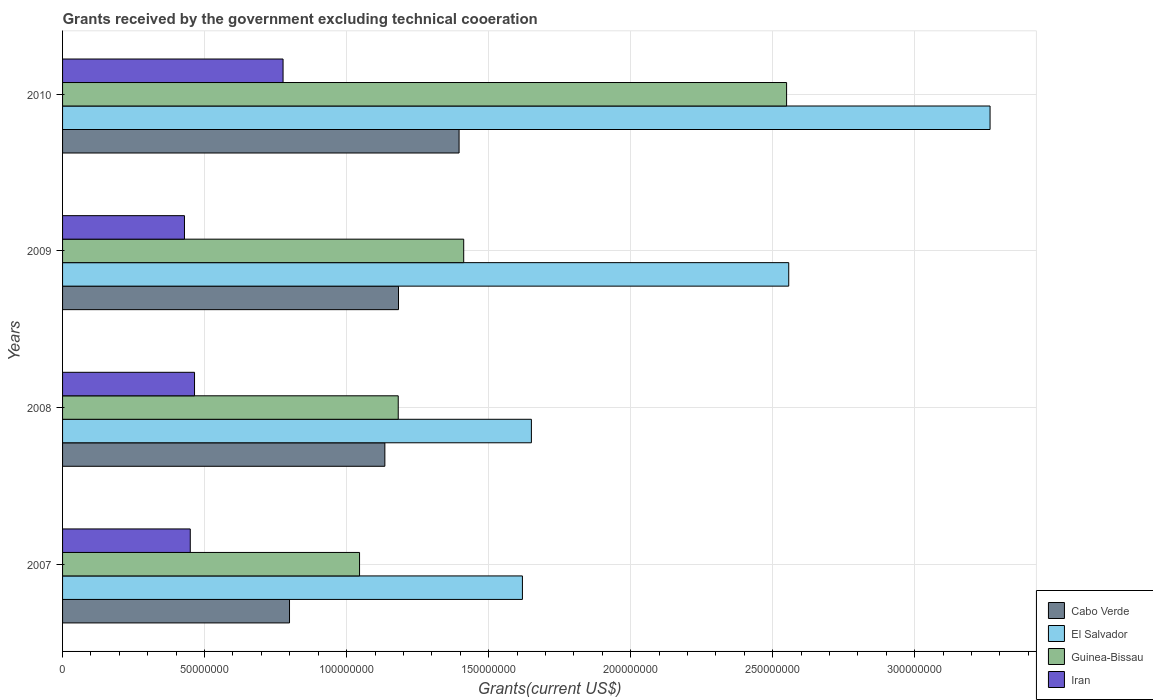How many different coloured bars are there?
Keep it short and to the point. 4. What is the label of the 2nd group of bars from the top?
Give a very brief answer. 2009. In how many cases, is the number of bars for a given year not equal to the number of legend labels?
Your answer should be compact. 0. What is the total grants received by the government in El Salvador in 2008?
Provide a succinct answer. 1.65e+08. Across all years, what is the maximum total grants received by the government in Guinea-Bissau?
Make the answer very short. 2.55e+08. Across all years, what is the minimum total grants received by the government in Cabo Verde?
Keep it short and to the point. 7.99e+07. What is the total total grants received by the government in El Salvador in the graph?
Offer a terse response. 9.09e+08. What is the difference between the total grants received by the government in El Salvador in 2009 and that in 2010?
Make the answer very short. -7.09e+07. What is the difference between the total grants received by the government in Cabo Verde in 2010 and the total grants received by the government in Guinea-Bissau in 2009?
Offer a very short reply. -1.63e+06. What is the average total grants received by the government in Iran per year?
Your response must be concise. 5.30e+07. In the year 2009, what is the difference between the total grants received by the government in Guinea-Bissau and total grants received by the government in Iran?
Offer a very short reply. 9.83e+07. In how many years, is the total grants received by the government in Iran greater than 70000000 US$?
Make the answer very short. 1. What is the ratio of the total grants received by the government in Iran in 2008 to that in 2010?
Offer a very short reply. 0.6. What is the difference between the highest and the second highest total grants received by the government in Guinea-Bissau?
Your answer should be compact. 1.14e+08. What is the difference between the highest and the lowest total grants received by the government in Guinea-Bissau?
Ensure brevity in your answer.  1.50e+08. In how many years, is the total grants received by the government in Cabo Verde greater than the average total grants received by the government in Cabo Verde taken over all years?
Provide a short and direct response. 3. Is it the case that in every year, the sum of the total grants received by the government in Cabo Verde and total grants received by the government in Iran is greater than the sum of total grants received by the government in El Salvador and total grants received by the government in Guinea-Bissau?
Your response must be concise. Yes. What does the 1st bar from the top in 2007 represents?
Ensure brevity in your answer.  Iran. What does the 4th bar from the bottom in 2009 represents?
Provide a short and direct response. Iran. Is it the case that in every year, the sum of the total grants received by the government in Iran and total grants received by the government in El Salvador is greater than the total grants received by the government in Guinea-Bissau?
Your answer should be compact. Yes. How many bars are there?
Provide a short and direct response. 16. What is the difference between two consecutive major ticks on the X-axis?
Ensure brevity in your answer.  5.00e+07. Are the values on the major ticks of X-axis written in scientific E-notation?
Your response must be concise. No. Does the graph contain any zero values?
Your answer should be very brief. No. Does the graph contain grids?
Your answer should be very brief. Yes. Where does the legend appear in the graph?
Offer a very short reply. Bottom right. How many legend labels are there?
Offer a terse response. 4. How are the legend labels stacked?
Provide a succinct answer. Vertical. What is the title of the graph?
Ensure brevity in your answer.  Grants received by the government excluding technical cooeration. Does "Lithuania" appear as one of the legend labels in the graph?
Ensure brevity in your answer.  No. What is the label or title of the X-axis?
Provide a succinct answer. Grants(current US$). What is the Grants(current US$) of Cabo Verde in 2007?
Your response must be concise. 7.99e+07. What is the Grants(current US$) of El Salvador in 2007?
Make the answer very short. 1.62e+08. What is the Grants(current US$) of Guinea-Bissau in 2007?
Offer a terse response. 1.05e+08. What is the Grants(current US$) in Iran in 2007?
Keep it short and to the point. 4.50e+07. What is the Grants(current US$) of Cabo Verde in 2008?
Your response must be concise. 1.13e+08. What is the Grants(current US$) in El Salvador in 2008?
Provide a succinct answer. 1.65e+08. What is the Grants(current US$) of Guinea-Bissau in 2008?
Keep it short and to the point. 1.18e+08. What is the Grants(current US$) of Iran in 2008?
Make the answer very short. 4.65e+07. What is the Grants(current US$) of Cabo Verde in 2009?
Provide a short and direct response. 1.18e+08. What is the Grants(current US$) in El Salvador in 2009?
Make the answer very short. 2.56e+08. What is the Grants(current US$) of Guinea-Bissau in 2009?
Offer a terse response. 1.41e+08. What is the Grants(current US$) in Iran in 2009?
Ensure brevity in your answer.  4.29e+07. What is the Grants(current US$) of Cabo Verde in 2010?
Keep it short and to the point. 1.40e+08. What is the Grants(current US$) of El Salvador in 2010?
Provide a succinct answer. 3.27e+08. What is the Grants(current US$) in Guinea-Bissau in 2010?
Offer a terse response. 2.55e+08. What is the Grants(current US$) of Iran in 2010?
Give a very brief answer. 7.76e+07. Across all years, what is the maximum Grants(current US$) of Cabo Verde?
Your answer should be very brief. 1.40e+08. Across all years, what is the maximum Grants(current US$) of El Salvador?
Offer a very short reply. 3.27e+08. Across all years, what is the maximum Grants(current US$) in Guinea-Bissau?
Offer a very short reply. 2.55e+08. Across all years, what is the maximum Grants(current US$) of Iran?
Provide a short and direct response. 7.76e+07. Across all years, what is the minimum Grants(current US$) of Cabo Verde?
Give a very brief answer. 7.99e+07. Across all years, what is the minimum Grants(current US$) of El Salvador?
Keep it short and to the point. 1.62e+08. Across all years, what is the minimum Grants(current US$) of Guinea-Bissau?
Give a very brief answer. 1.05e+08. Across all years, what is the minimum Grants(current US$) of Iran?
Give a very brief answer. 4.29e+07. What is the total Grants(current US$) of Cabo Verde in the graph?
Provide a succinct answer. 4.51e+08. What is the total Grants(current US$) in El Salvador in the graph?
Your answer should be compact. 9.09e+08. What is the total Grants(current US$) of Guinea-Bissau in the graph?
Ensure brevity in your answer.  6.19e+08. What is the total Grants(current US$) in Iran in the graph?
Offer a very short reply. 2.12e+08. What is the difference between the Grants(current US$) of Cabo Verde in 2007 and that in 2008?
Provide a succinct answer. -3.36e+07. What is the difference between the Grants(current US$) of El Salvador in 2007 and that in 2008?
Offer a very short reply. -3.16e+06. What is the difference between the Grants(current US$) in Guinea-Bissau in 2007 and that in 2008?
Give a very brief answer. -1.36e+07. What is the difference between the Grants(current US$) of Iran in 2007 and that in 2008?
Offer a terse response. -1.50e+06. What is the difference between the Grants(current US$) of Cabo Verde in 2007 and that in 2009?
Your response must be concise. -3.84e+07. What is the difference between the Grants(current US$) in El Salvador in 2007 and that in 2009?
Provide a short and direct response. -9.38e+07. What is the difference between the Grants(current US$) in Guinea-Bissau in 2007 and that in 2009?
Your response must be concise. -3.67e+07. What is the difference between the Grants(current US$) of Iran in 2007 and that in 2009?
Your answer should be very brief. 2.04e+06. What is the difference between the Grants(current US$) of Cabo Verde in 2007 and that in 2010?
Give a very brief answer. -5.97e+07. What is the difference between the Grants(current US$) of El Salvador in 2007 and that in 2010?
Provide a succinct answer. -1.65e+08. What is the difference between the Grants(current US$) in Guinea-Bissau in 2007 and that in 2010?
Provide a short and direct response. -1.50e+08. What is the difference between the Grants(current US$) of Iran in 2007 and that in 2010?
Ensure brevity in your answer.  -3.27e+07. What is the difference between the Grants(current US$) in Cabo Verde in 2008 and that in 2009?
Make the answer very short. -4.80e+06. What is the difference between the Grants(current US$) in El Salvador in 2008 and that in 2009?
Provide a short and direct response. -9.06e+07. What is the difference between the Grants(current US$) in Guinea-Bissau in 2008 and that in 2009?
Keep it short and to the point. -2.30e+07. What is the difference between the Grants(current US$) in Iran in 2008 and that in 2009?
Ensure brevity in your answer.  3.54e+06. What is the difference between the Grants(current US$) in Cabo Verde in 2008 and that in 2010?
Keep it short and to the point. -2.61e+07. What is the difference between the Grants(current US$) of El Salvador in 2008 and that in 2010?
Your response must be concise. -1.61e+08. What is the difference between the Grants(current US$) of Guinea-Bissau in 2008 and that in 2010?
Your response must be concise. -1.37e+08. What is the difference between the Grants(current US$) of Iran in 2008 and that in 2010?
Ensure brevity in your answer.  -3.12e+07. What is the difference between the Grants(current US$) in Cabo Verde in 2009 and that in 2010?
Give a very brief answer. -2.13e+07. What is the difference between the Grants(current US$) of El Salvador in 2009 and that in 2010?
Offer a terse response. -7.09e+07. What is the difference between the Grants(current US$) in Guinea-Bissau in 2009 and that in 2010?
Ensure brevity in your answer.  -1.14e+08. What is the difference between the Grants(current US$) of Iran in 2009 and that in 2010?
Offer a very short reply. -3.47e+07. What is the difference between the Grants(current US$) of Cabo Verde in 2007 and the Grants(current US$) of El Salvador in 2008?
Offer a very short reply. -8.52e+07. What is the difference between the Grants(current US$) of Cabo Verde in 2007 and the Grants(current US$) of Guinea-Bissau in 2008?
Provide a succinct answer. -3.83e+07. What is the difference between the Grants(current US$) of Cabo Verde in 2007 and the Grants(current US$) of Iran in 2008?
Provide a short and direct response. 3.34e+07. What is the difference between the Grants(current US$) in El Salvador in 2007 and the Grants(current US$) in Guinea-Bissau in 2008?
Your answer should be very brief. 4.37e+07. What is the difference between the Grants(current US$) in El Salvador in 2007 and the Grants(current US$) in Iran in 2008?
Offer a very short reply. 1.15e+08. What is the difference between the Grants(current US$) of Guinea-Bissau in 2007 and the Grants(current US$) of Iran in 2008?
Keep it short and to the point. 5.81e+07. What is the difference between the Grants(current US$) in Cabo Verde in 2007 and the Grants(current US$) in El Salvador in 2009?
Your answer should be very brief. -1.76e+08. What is the difference between the Grants(current US$) in Cabo Verde in 2007 and the Grants(current US$) in Guinea-Bissau in 2009?
Make the answer very short. -6.13e+07. What is the difference between the Grants(current US$) in Cabo Verde in 2007 and the Grants(current US$) in Iran in 2009?
Provide a short and direct response. 3.70e+07. What is the difference between the Grants(current US$) of El Salvador in 2007 and the Grants(current US$) of Guinea-Bissau in 2009?
Your answer should be compact. 2.07e+07. What is the difference between the Grants(current US$) of El Salvador in 2007 and the Grants(current US$) of Iran in 2009?
Offer a very short reply. 1.19e+08. What is the difference between the Grants(current US$) of Guinea-Bissau in 2007 and the Grants(current US$) of Iran in 2009?
Offer a terse response. 6.16e+07. What is the difference between the Grants(current US$) in Cabo Verde in 2007 and the Grants(current US$) in El Salvador in 2010?
Your response must be concise. -2.47e+08. What is the difference between the Grants(current US$) in Cabo Verde in 2007 and the Grants(current US$) in Guinea-Bissau in 2010?
Provide a short and direct response. -1.75e+08. What is the difference between the Grants(current US$) of Cabo Verde in 2007 and the Grants(current US$) of Iran in 2010?
Your answer should be compact. 2.27e+06. What is the difference between the Grants(current US$) in El Salvador in 2007 and the Grants(current US$) in Guinea-Bissau in 2010?
Your answer should be compact. -9.30e+07. What is the difference between the Grants(current US$) in El Salvador in 2007 and the Grants(current US$) in Iran in 2010?
Offer a very short reply. 8.43e+07. What is the difference between the Grants(current US$) in Guinea-Bissau in 2007 and the Grants(current US$) in Iran in 2010?
Ensure brevity in your answer.  2.69e+07. What is the difference between the Grants(current US$) in Cabo Verde in 2008 and the Grants(current US$) in El Salvador in 2009?
Keep it short and to the point. -1.42e+08. What is the difference between the Grants(current US$) in Cabo Verde in 2008 and the Grants(current US$) in Guinea-Bissau in 2009?
Offer a terse response. -2.78e+07. What is the difference between the Grants(current US$) in Cabo Verde in 2008 and the Grants(current US$) in Iran in 2009?
Offer a terse response. 7.06e+07. What is the difference between the Grants(current US$) of El Salvador in 2008 and the Grants(current US$) of Guinea-Bissau in 2009?
Provide a succinct answer. 2.38e+07. What is the difference between the Grants(current US$) of El Salvador in 2008 and the Grants(current US$) of Iran in 2009?
Provide a short and direct response. 1.22e+08. What is the difference between the Grants(current US$) of Guinea-Bissau in 2008 and the Grants(current US$) of Iran in 2009?
Provide a succinct answer. 7.53e+07. What is the difference between the Grants(current US$) in Cabo Verde in 2008 and the Grants(current US$) in El Salvador in 2010?
Offer a very short reply. -2.13e+08. What is the difference between the Grants(current US$) of Cabo Verde in 2008 and the Grants(current US$) of Guinea-Bissau in 2010?
Your answer should be compact. -1.41e+08. What is the difference between the Grants(current US$) in Cabo Verde in 2008 and the Grants(current US$) in Iran in 2010?
Ensure brevity in your answer.  3.58e+07. What is the difference between the Grants(current US$) of El Salvador in 2008 and the Grants(current US$) of Guinea-Bissau in 2010?
Keep it short and to the point. -8.98e+07. What is the difference between the Grants(current US$) in El Salvador in 2008 and the Grants(current US$) in Iran in 2010?
Ensure brevity in your answer.  8.74e+07. What is the difference between the Grants(current US$) in Guinea-Bissau in 2008 and the Grants(current US$) in Iran in 2010?
Your answer should be very brief. 4.06e+07. What is the difference between the Grants(current US$) in Cabo Verde in 2009 and the Grants(current US$) in El Salvador in 2010?
Your response must be concise. -2.08e+08. What is the difference between the Grants(current US$) of Cabo Verde in 2009 and the Grants(current US$) of Guinea-Bissau in 2010?
Offer a terse response. -1.37e+08. What is the difference between the Grants(current US$) of Cabo Verde in 2009 and the Grants(current US$) of Iran in 2010?
Your answer should be compact. 4.06e+07. What is the difference between the Grants(current US$) of El Salvador in 2009 and the Grants(current US$) of Guinea-Bissau in 2010?
Provide a short and direct response. 7.50e+05. What is the difference between the Grants(current US$) in El Salvador in 2009 and the Grants(current US$) in Iran in 2010?
Your answer should be compact. 1.78e+08. What is the difference between the Grants(current US$) of Guinea-Bissau in 2009 and the Grants(current US$) of Iran in 2010?
Your answer should be compact. 6.36e+07. What is the average Grants(current US$) in Cabo Verde per year?
Give a very brief answer. 1.13e+08. What is the average Grants(current US$) in El Salvador per year?
Make the answer very short. 2.27e+08. What is the average Grants(current US$) of Guinea-Bissau per year?
Your response must be concise. 1.55e+08. What is the average Grants(current US$) of Iran per year?
Your answer should be very brief. 5.30e+07. In the year 2007, what is the difference between the Grants(current US$) of Cabo Verde and Grants(current US$) of El Salvador?
Give a very brief answer. -8.20e+07. In the year 2007, what is the difference between the Grants(current US$) in Cabo Verde and Grants(current US$) in Guinea-Bissau?
Give a very brief answer. -2.47e+07. In the year 2007, what is the difference between the Grants(current US$) of Cabo Verde and Grants(current US$) of Iran?
Offer a terse response. 3.49e+07. In the year 2007, what is the difference between the Grants(current US$) in El Salvador and Grants(current US$) in Guinea-Bissau?
Offer a very short reply. 5.73e+07. In the year 2007, what is the difference between the Grants(current US$) in El Salvador and Grants(current US$) in Iran?
Your response must be concise. 1.17e+08. In the year 2007, what is the difference between the Grants(current US$) of Guinea-Bissau and Grants(current US$) of Iran?
Provide a short and direct response. 5.96e+07. In the year 2008, what is the difference between the Grants(current US$) in Cabo Verde and Grants(current US$) in El Salvador?
Ensure brevity in your answer.  -5.16e+07. In the year 2008, what is the difference between the Grants(current US$) in Cabo Verde and Grants(current US$) in Guinea-Bissau?
Keep it short and to the point. -4.71e+06. In the year 2008, what is the difference between the Grants(current US$) in Cabo Verde and Grants(current US$) in Iran?
Your response must be concise. 6.70e+07. In the year 2008, what is the difference between the Grants(current US$) in El Salvador and Grants(current US$) in Guinea-Bissau?
Keep it short and to the point. 4.69e+07. In the year 2008, what is the difference between the Grants(current US$) in El Salvador and Grants(current US$) in Iran?
Ensure brevity in your answer.  1.19e+08. In the year 2008, what is the difference between the Grants(current US$) of Guinea-Bissau and Grants(current US$) of Iran?
Your answer should be very brief. 7.17e+07. In the year 2009, what is the difference between the Grants(current US$) in Cabo Verde and Grants(current US$) in El Salvador?
Your answer should be compact. -1.37e+08. In the year 2009, what is the difference between the Grants(current US$) of Cabo Verde and Grants(current US$) of Guinea-Bissau?
Provide a succinct answer. -2.30e+07. In the year 2009, what is the difference between the Grants(current US$) in Cabo Verde and Grants(current US$) in Iran?
Offer a very short reply. 7.54e+07. In the year 2009, what is the difference between the Grants(current US$) of El Salvador and Grants(current US$) of Guinea-Bissau?
Keep it short and to the point. 1.14e+08. In the year 2009, what is the difference between the Grants(current US$) in El Salvador and Grants(current US$) in Iran?
Ensure brevity in your answer.  2.13e+08. In the year 2009, what is the difference between the Grants(current US$) of Guinea-Bissau and Grants(current US$) of Iran?
Give a very brief answer. 9.83e+07. In the year 2010, what is the difference between the Grants(current US$) in Cabo Verde and Grants(current US$) in El Salvador?
Ensure brevity in your answer.  -1.87e+08. In the year 2010, what is the difference between the Grants(current US$) in Cabo Verde and Grants(current US$) in Guinea-Bissau?
Keep it short and to the point. -1.15e+08. In the year 2010, what is the difference between the Grants(current US$) of Cabo Verde and Grants(current US$) of Iran?
Give a very brief answer. 6.20e+07. In the year 2010, what is the difference between the Grants(current US$) of El Salvador and Grants(current US$) of Guinea-Bissau?
Your response must be concise. 7.16e+07. In the year 2010, what is the difference between the Grants(current US$) of El Salvador and Grants(current US$) of Iran?
Provide a succinct answer. 2.49e+08. In the year 2010, what is the difference between the Grants(current US$) of Guinea-Bissau and Grants(current US$) of Iran?
Offer a terse response. 1.77e+08. What is the ratio of the Grants(current US$) in Cabo Verde in 2007 to that in 2008?
Offer a very short reply. 0.7. What is the ratio of the Grants(current US$) in El Salvador in 2007 to that in 2008?
Give a very brief answer. 0.98. What is the ratio of the Grants(current US$) in Guinea-Bissau in 2007 to that in 2008?
Your response must be concise. 0.88. What is the ratio of the Grants(current US$) of Cabo Verde in 2007 to that in 2009?
Provide a short and direct response. 0.68. What is the ratio of the Grants(current US$) in El Salvador in 2007 to that in 2009?
Your response must be concise. 0.63. What is the ratio of the Grants(current US$) of Guinea-Bissau in 2007 to that in 2009?
Offer a very short reply. 0.74. What is the ratio of the Grants(current US$) of Iran in 2007 to that in 2009?
Offer a very short reply. 1.05. What is the ratio of the Grants(current US$) in Cabo Verde in 2007 to that in 2010?
Your response must be concise. 0.57. What is the ratio of the Grants(current US$) of El Salvador in 2007 to that in 2010?
Ensure brevity in your answer.  0.5. What is the ratio of the Grants(current US$) in Guinea-Bissau in 2007 to that in 2010?
Keep it short and to the point. 0.41. What is the ratio of the Grants(current US$) of Iran in 2007 to that in 2010?
Your answer should be compact. 0.58. What is the ratio of the Grants(current US$) in Cabo Verde in 2008 to that in 2009?
Your response must be concise. 0.96. What is the ratio of the Grants(current US$) of El Salvador in 2008 to that in 2009?
Make the answer very short. 0.65. What is the ratio of the Grants(current US$) of Guinea-Bissau in 2008 to that in 2009?
Provide a succinct answer. 0.84. What is the ratio of the Grants(current US$) in Iran in 2008 to that in 2009?
Make the answer very short. 1.08. What is the ratio of the Grants(current US$) in Cabo Verde in 2008 to that in 2010?
Ensure brevity in your answer.  0.81. What is the ratio of the Grants(current US$) in El Salvador in 2008 to that in 2010?
Offer a very short reply. 0.51. What is the ratio of the Grants(current US$) of Guinea-Bissau in 2008 to that in 2010?
Offer a terse response. 0.46. What is the ratio of the Grants(current US$) of Iran in 2008 to that in 2010?
Provide a short and direct response. 0.6. What is the ratio of the Grants(current US$) in Cabo Verde in 2009 to that in 2010?
Your answer should be compact. 0.85. What is the ratio of the Grants(current US$) in El Salvador in 2009 to that in 2010?
Provide a short and direct response. 0.78. What is the ratio of the Grants(current US$) of Guinea-Bissau in 2009 to that in 2010?
Offer a terse response. 0.55. What is the ratio of the Grants(current US$) of Iran in 2009 to that in 2010?
Provide a short and direct response. 0.55. What is the difference between the highest and the second highest Grants(current US$) of Cabo Verde?
Provide a short and direct response. 2.13e+07. What is the difference between the highest and the second highest Grants(current US$) of El Salvador?
Your answer should be very brief. 7.09e+07. What is the difference between the highest and the second highest Grants(current US$) of Guinea-Bissau?
Your response must be concise. 1.14e+08. What is the difference between the highest and the second highest Grants(current US$) of Iran?
Your response must be concise. 3.12e+07. What is the difference between the highest and the lowest Grants(current US$) in Cabo Verde?
Give a very brief answer. 5.97e+07. What is the difference between the highest and the lowest Grants(current US$) in El Salvador?
Provide a succinct answer. 1.65e+08. What is the difference between the highest and the lowest Grants(current US$) of Guinea-Bissau?
Give a very brief answer. 1.50e+08. What is the difference between the highest and the lowest Grants(current US$) in Iran?
Provide a short and direct response. 3.47e+07. 